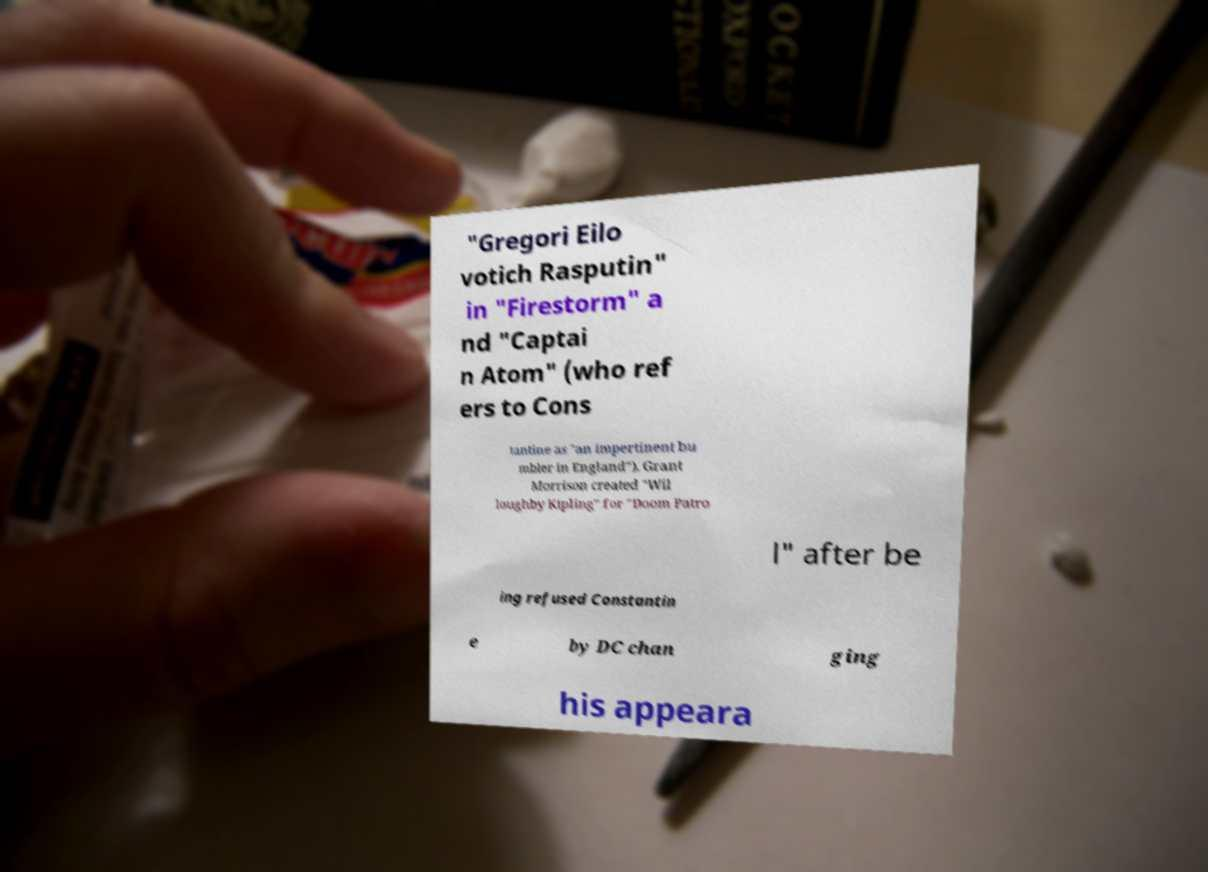For documentation purposes, I need the text within this image transcribed. Could you provide that? "Gregori Eilo votich Rasputin" in "Firestorm" a nd "Captai n Atom" (who ref ers to Cons tantine as "an impertinent bu mbler in England"). Grant Morrison created "Wil loughby Kipling" for "Doom Patro l" after be ing refused Constantin e by DC chan ging his appeara 